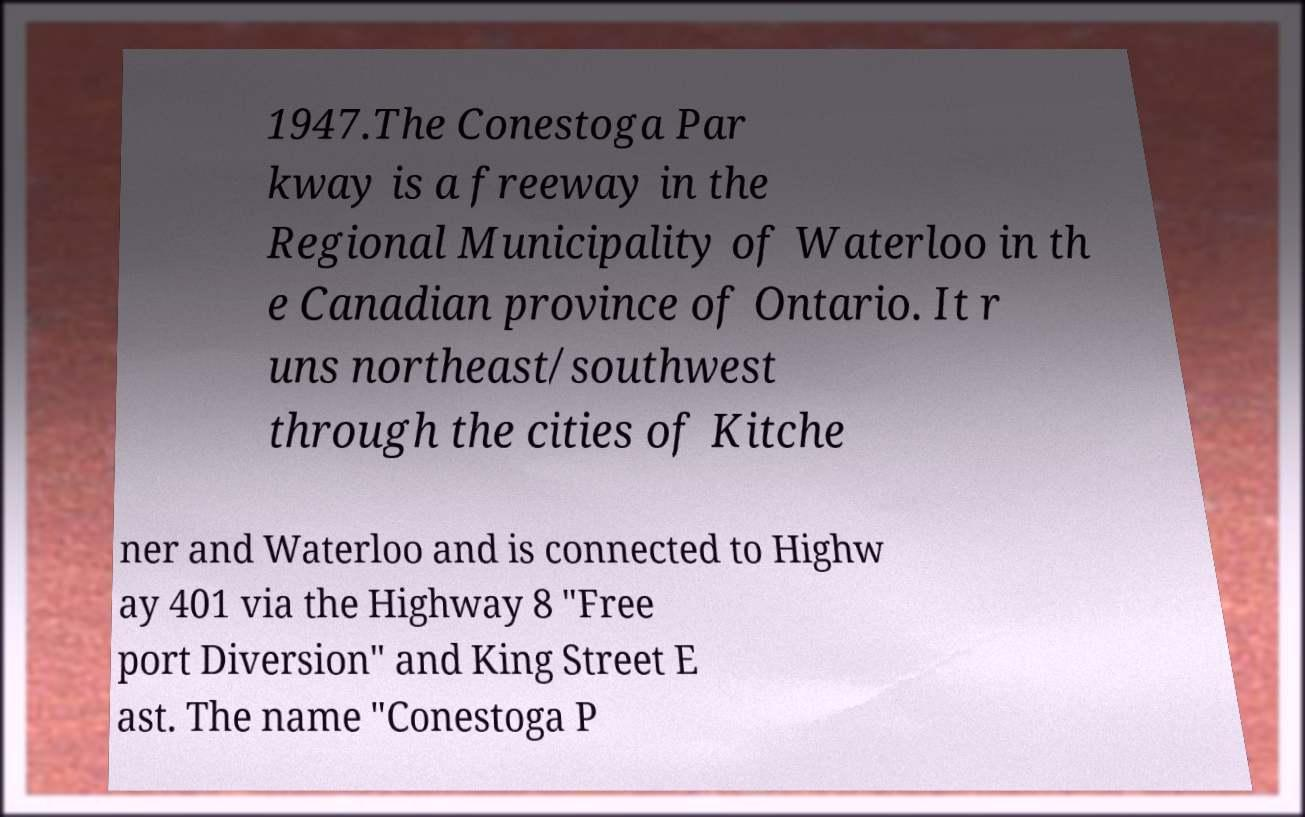Please identify and transcribe the text found in this image. 1947.The Conestoga Par kway is a freeway in the Regional Municipality of Waterloo in th e Canadian province of Ontario. It r uns northeast/southwest through the cities of Kitche ner and Waterloo and is connected to Highw ay 401 via the Highway 8 "Free port Diversion" and King Street E ast. The name "Conestoga P 